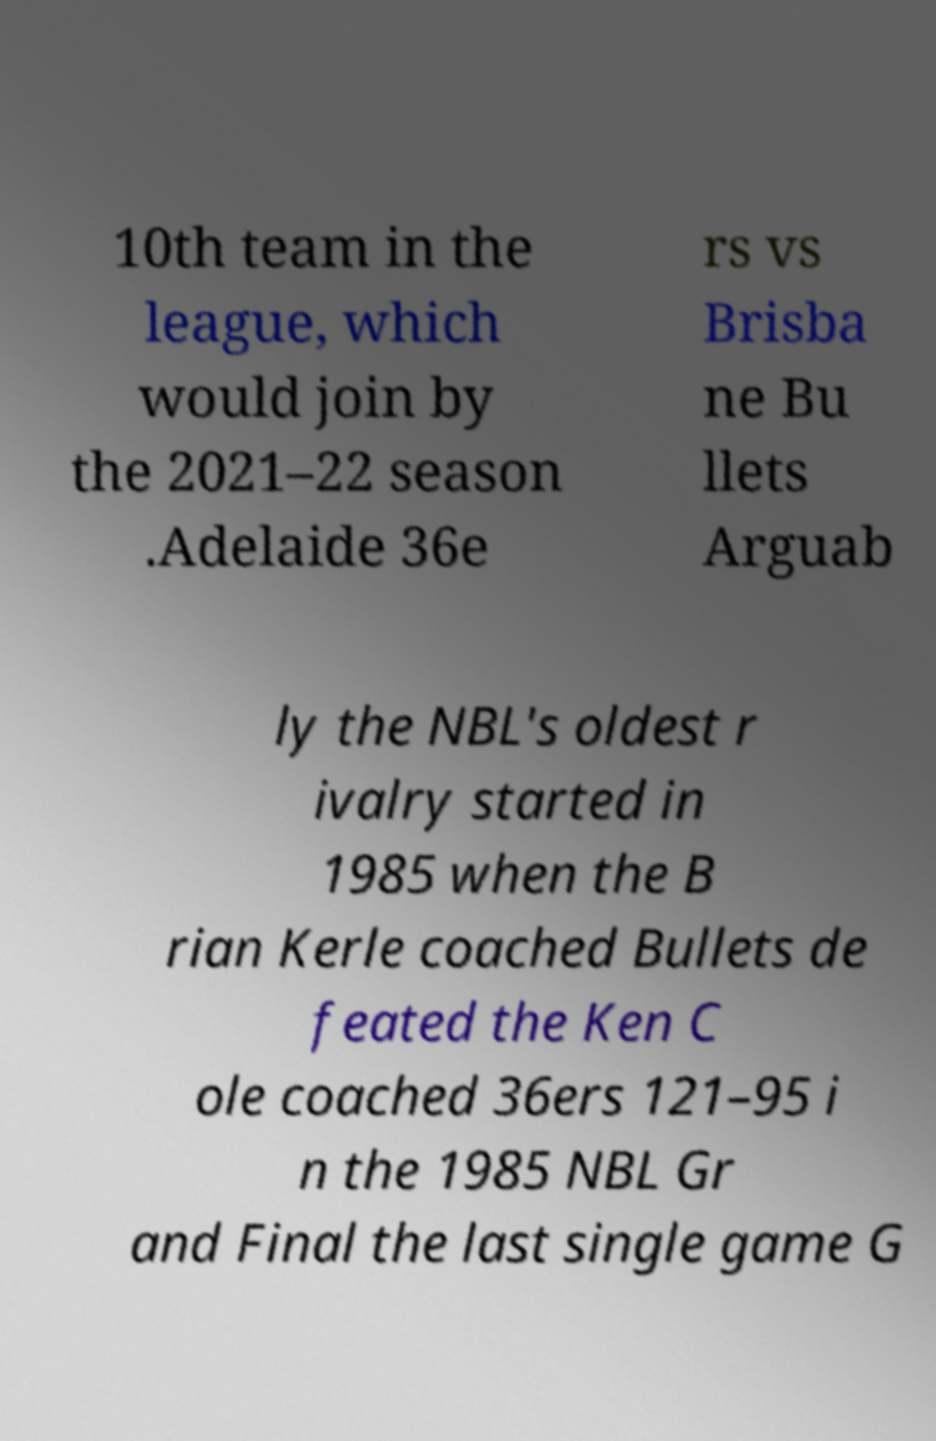For documentation purposes, I need the text within this image transcribed. Could you provide that? 10th team in the league, which would join by the 2021–22 season .Adelaide 36e rs vs Brisba ne Bu llets Arguab ly the NBL's oldest r ivalry started in 1985 when the B rian Kerle coached Bullets de feated the Ken C ole coached 36ers 121–95 i n the 1985 NBL Gr and Final the last single game G 